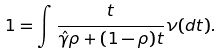<formula> <loc_0><loc_0><loc_500><loc_500>1 & = \int \frac { t } { { \hat { \gamma } } \rho + ( 1 - \rho ) t } \nu ( d t ) .</formula> 